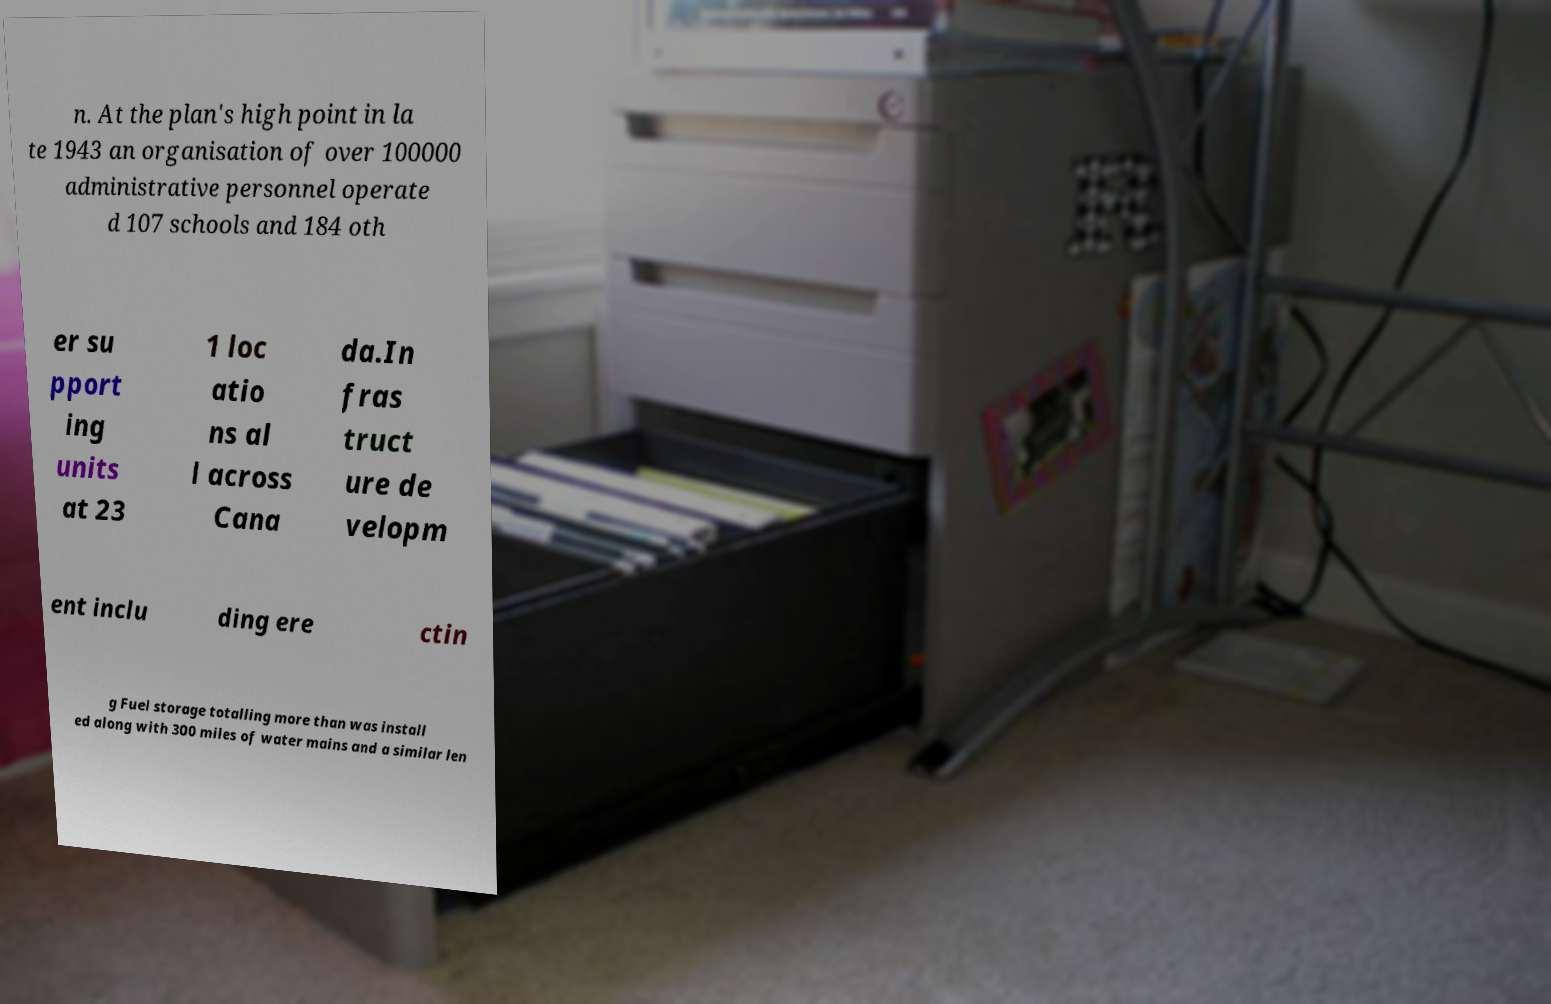For documentation purposes, I need the text within this image transcribed. Could you provide that? n. At the plan's high point in la te 1943 an organisation of over 100000 administrative personnel operate d 107 schools and 184 oth er su pport ing units at 23 1 loc atio ns al l across Cana da.In fras truct ure de velopm ent inclu ding ere ctin g Fuel storage totalling more than was install ed along with 300 miles of water mains and a similar len 